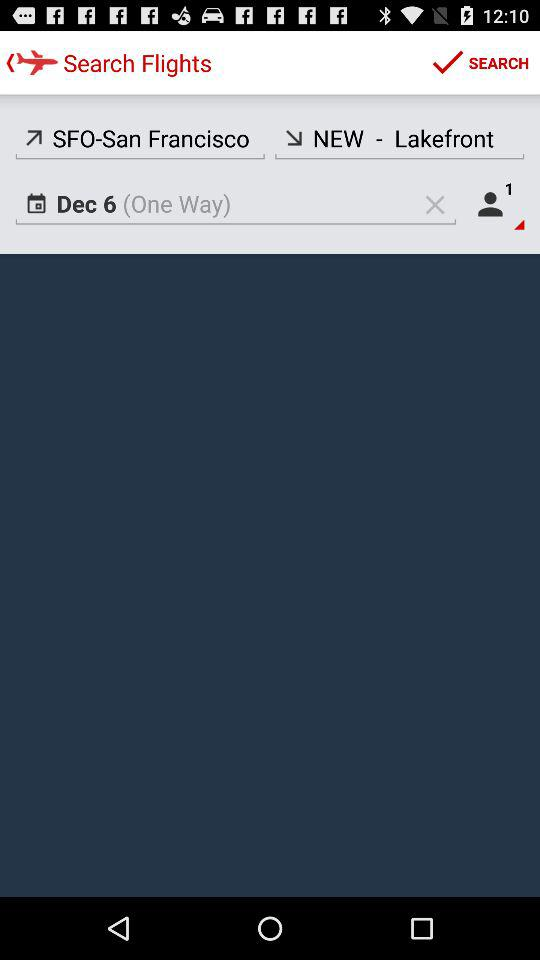What's the departure location? The departure location is SFO - San Francisco. 